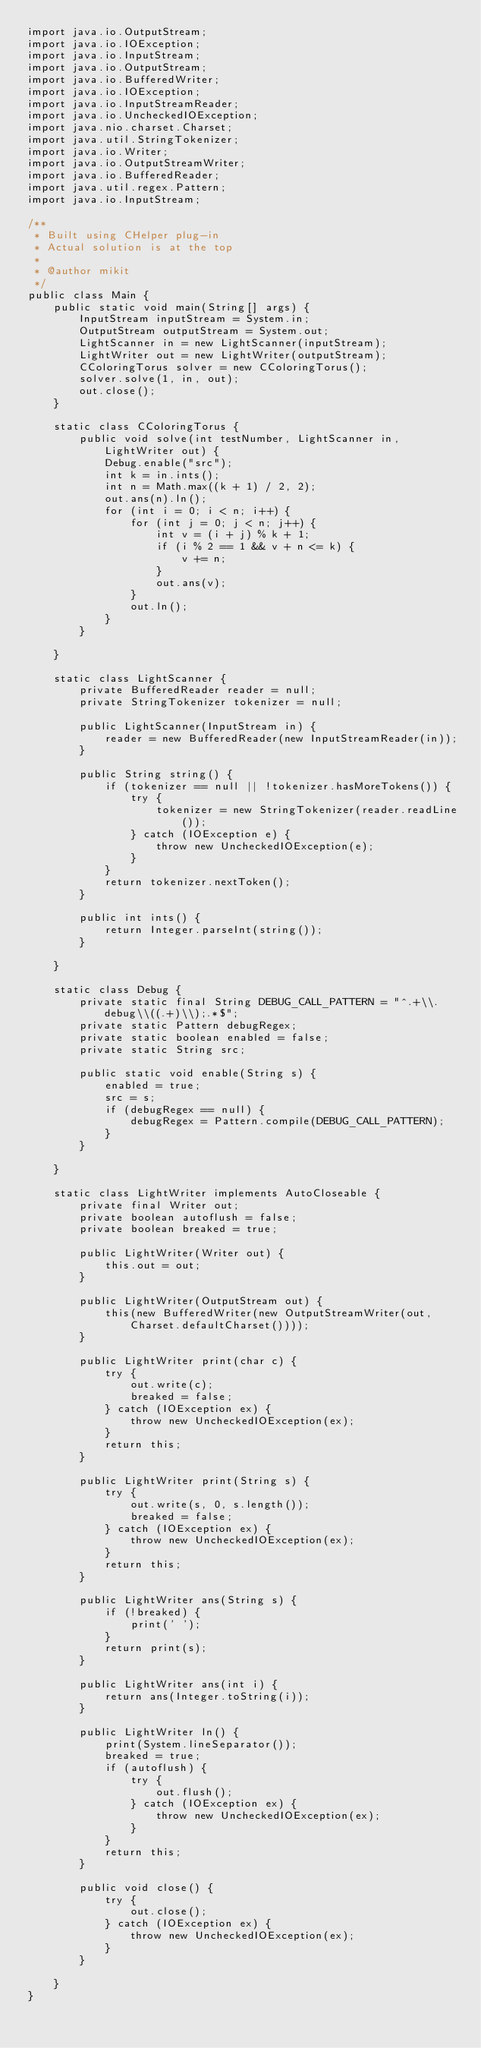<code> <loc_0><loc_0><loc_500><loc_500><_Java_>import java.io.OutputStream;
import java.io.IOException;
import java.io.InputStream;
import java.io.OutputStream;
import java.io.BufferedWriter;
import java.io.IOException;
import java.io.InputStreamReader;
import java.io.UncheckedIOException;
import java.nio.charset.Charset;
import java.util.StringTokenizer;
import java.io.Writer;
import java.io.OutputStreamWriter;
import java.io.BufferedReader;
import java.util.regex.Pattern;
import java.io.InputStream;

/**
 * Built using CHelper plug-in
 * Actual solution is at the top
 *
 * @author mikit
 */
public class Main {
    public static void main(String[] args) {
        InputStream inputStream = System.in;
        OutputStream outputStream = System.out;
        LightScanner in = new LightScanner(inputStream);
        LightWriter out = new LightWriter(outputStream);
        CColoringTorus solver = new CColoringTorus();
        solver.solve(1, in, out);
        out.close();
    }

    static class CColoringTorus {
        public void solve(int testNumber, LightScanner in, LightWriter out) {
            Debug.enable("src");
            int k = in.ints();
            int n = Math.max((k + 1) / 2, 2);
            out.ans(n).ln();
            for (int i = 0; i < n; i++) {
                for (int j = 0; j < n; j++) {
                    int v = (i + j) % k + 1;
                    if (i % 2 == 1 && v + n <= k) {
                        v += n;
                    }
                    out.ans(v);
                }
                out.ln();
            }
        }

    }

    static class LightScanner {
        private BufferedReader reader = null;
        private StringTokenizer tokenizer = null;

        public LightScanner(InputStream in) {
            reader = new BufferedReader(new InputStreamReader(in));
        }

        public String string() {
            if (tokenizer == null || !tokenizer.hasMoreTokens()) {
                try {
                    tokenizer = new StringTokenizer(reader.readLine());
                } catch (IOException e) {
                    throw new UncheckedIOException(e);
                }
            }
            return tokenizer.nextToken();
        }

        public int ints() {
            return Integer.parseInt(string());
        }

    }

    static class Debug {
        private static final String DEBUG_CALL_PATTERN = "^.+\\.debug\\((.+)\\);.*$";
        private static Pattern debugRegex;
        private static boolean enabled = false;
        private static String src;

        public static void enable(String s) {
            enabled = true;
            src = s;
            if (debugRegex == null) {
                debugRegex = Pattern.compile(DEBUG_CALL_PATTERN);
            }
        }

    }

    static class LightWriter implements AutoCloseable {
        private final Writer out;
        private boolean autoflush = false;
        private boolean breaked = true;

        public LightWriter(Writer out) {
            this.out = out;
        }

        public LightWriter(OutputStream out) {
            this(new BufferedWriter(new OutputStreamWriter(out, Charset.defaultCharset())));
        }

        public LightWriter print(char c) {
            try {
                out.write(c);
                breaked = false;
            } catch (IOException ex) {
                throw new UncheckedIOException(ex);
            }
            return this;
        }

        public LightWriter print(String s) {
            try {
                out.write(s, 0, s.length());
                breaked = false;
            } catch (IOException ex) {
                throw new UncheckedIOException(ex);
            }
            return this;
        }

        public LightWriter ans(String s) {
            if (!breaked) {
                print(' ');
            }
            return print(s);
        }

        public LightWriter ans(int i) {
            return ans(Integer.toString(i));
        }

        public LightWriter ln() {
            print(System.lineSeparator());
            breaked = true;
            if (autoflush) {
                try {
                    out.flush();
                } catch (IOException ex) {
                    throw new UncheckedIOException(ex);
                }
            }
            return this;
        }

        public void close() {
            try {
                out.close();
            } catch (IOException ex) {
                throw new UncheckedIOException(ex);
            }
        }

    }
}

</code> 